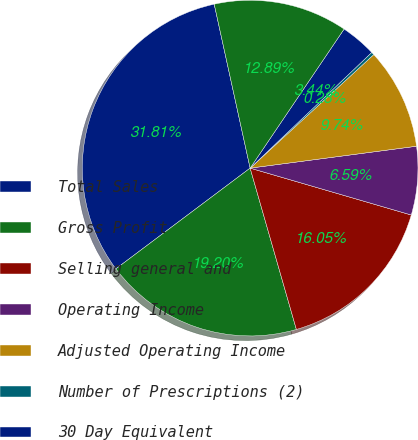Convert chart to OTSL. <chart><loc_0><loc_0><loc_500><loc_500><pie_chart><fcel>Total Sales<fcel>Gross Profit<fcel>Selling general and<fcel>Operating Income<fcel>Adjusted Operating Income<fcel>Number of Prescriptions (2)<fcel>30 Day Equivalent<fcel>Number of Locations at period<nl><fcel>31.81%<fcel>19.2%<fcel>16.05%<fcel>6.59%<fcel>9.74%<fcel>0.28%<fcel>3.44%<fcel>12.89%<nl></chart> 